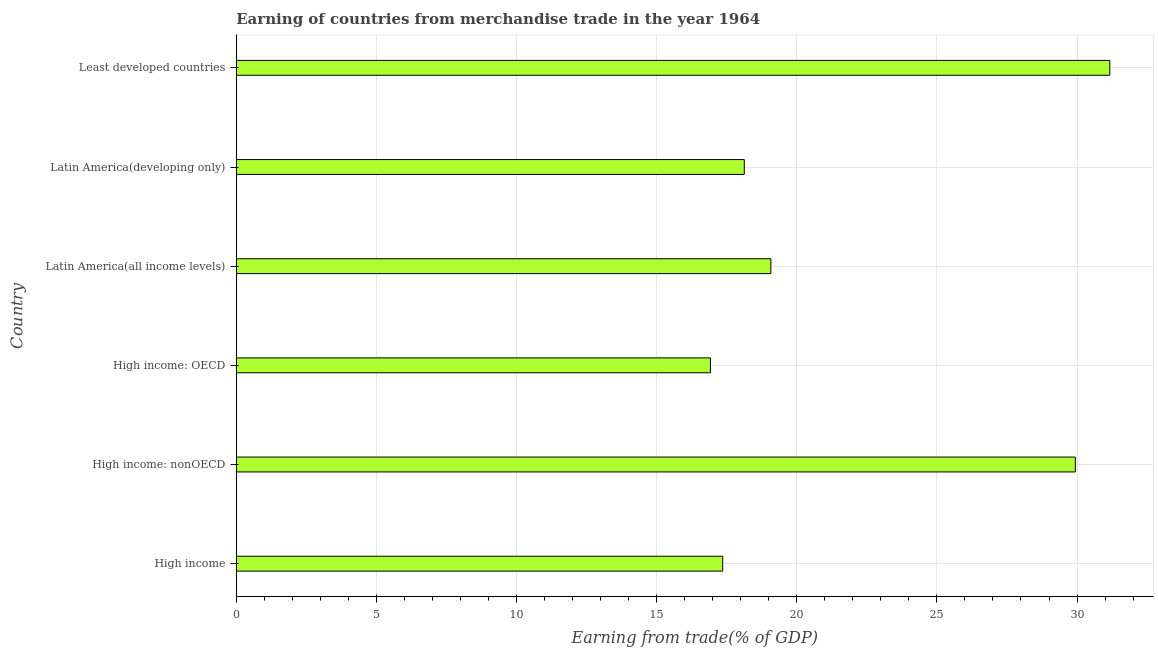Does the graph contain grids?
Your answer should be compact. Yes. What is the title of the graph?
Provide a short and direct response. Earning of countries from merchandise trade in the year 1964. What is the label or title of the X-axis?
Ensure brevity in your answer.  Earning from trade(% of GDP). What is the label or title of the Y-axis?
Your answer should be compact. Country. What is the earning from merchandise trade in High income: nonOECD?
Give a very brief answer. 29.94. Across all countries, what is the maximum earning from merchandise trade?
Provide a succinct answer. 31.17. Across all countries, what is the minimum earning from merchandise trade?
Offer a very short reply. 16.92. In which country was the earning from merchandise trade maximum?
Keep it short and to the point. Least developed countries. In which country was the earning from merchandise trade minimum?
Ensure brevity in your answer.  High income: OECD. What is the sum of the earning from merchandise trade?
Your answer should be compact. 132.59. What is the difference between the earning from merchandise trade in High income: OECD and Latin America(developing only)?
Your response must be concise. -1.21. What is the average earning from merchandise trade per country?
Your response must be concise. 22.1. What is the median earning from merchandise trade?
Keep it short and to the point. 18.6. What is the ratio of the earning from merchandise trade in High income to that in High income: nonOECD?
Keep it short and to the point. 0.58. Is the earning from merchandise trade in High income: OECD less than that in Latin America(developing only)?
Provide a short and direct response. Yes. What is the difference between the highest and the second highest earning from merchandise trade?
Give a very brief answer. 1.23. What is the difference between the highest and the lowest earning from merchandise trade?
Make the answer very short. 14.25. In how many countries, is the earning from merchandise trade greater than the average earning from merchandise trade taken over all countries?
Give a very brief answer. 2. Are all the bars in the graph horizontal?
Give a very brief answer. Yes. Are the values on the major ticks of X-axis written in scientific E-notation?
Provide a succinct answer. No. What is the Earning from trade(% of GDP) in High income?
Provide a short and direct response. 17.36. What is the Earning from trade(% of GDP) of High income: nonOECD?
Your answer should be very brief. 29.94. What is the Earning from trade(% of GDP) in High income: OECD?
Your response must be concise. 16.92. What is the Earning from trade(% of GDP) in Latin America(all income levels)?
Provide a succinct answer. 19.08. What is the Earning from trade(% of GDP) of Latin America(developing only)?
Ensure brevity in your answer.  18.13. What is the Earning from trade(% of GDP) of Least developed countries?
Provide a succinct answer. 31.17. What is the difference between the Earning from trade(% of GDP) in High income and High income: nonOECD?
Offer a very short reply. -12.58. What is the difference between the Earning from trade(% of GDP) in High income and High income: OECD?
Give a very brief answer. 0.44. What is the difference between the Earning from trade(% of GDP) in High income and Latin America(all income levels)?
Your answer should be very brief. -1.72. What is the difference between the Earning from trade(% of GDP) in High income and Latin America(developing only)?
Your answer should be compact. -0.77. What is the difference between the Earning from trade(% of GDP) in High income and Least developed countries?
Keep it short and to the point. -13.81. What is the difference between the Earning from trade(% of GDP) in High income: nonOECD and High income: OECD?
Ensure brevity in your answer.  13.02. What is the difference between the Earning from trade(% of GDP) in High income: nonOECD and Latin America(all income levels)?
Provide a succinct answer. 10.86. What is the difference between the Earning from trade(% of GDP) in High income: nonOECD and Latin America(developing only)?
Offer a terse response. 11.81. What is the difference between the Earning from trade(% of GDP) in High income: nonOECD and Least developed countries?
Your answer should be compact. -1.23. What is the difference between the Earning from trade(% of GDP) in High income: OECD and Latin America(all income levels)?
Your response must be concise. -2.16. What is the difference between the Earning from trade(% of GDP) in High income: OECD and Latin America(developing only)?
Offer a terse response. -1.21. What is the difference between the Earning from trade(% of GDP) in High income: OECD and Least developed countries?
Offer a very short reply. -14.25. What is the difference between the Earning from trade(% of GDP) in Latin America(all income levels) and Latin America(developing only)?
Give a very brief answer. 0.95. What is the difference between the Earning from trade(% of GDP) in Latin America(all income levels) and Least developed countries?
Give a very brief answer. -12.09. What is the difference between the Earning from trade(% of GDP) in Latin America(developing only) and Least developed countries?
Make the answer very short. -13.04. What is the ratio of the Earning from trade(% of GDP) in High income to that in High income: nonOECD?
Provide a succinct answer. 0.58. What is the ratio of the Earning from trade(% of GDP) in High income to that in Latin America(all income levels)?
Provide a succinct answer. 0.91. What is the ratio of the Earning from trade(% of GDP) in High income to that in Least developed countries?
Ensure brevity in your answer.  0.56. What is the ratio of the Earning from trade(% of GDP) in High income: nonOECD to that in High income: OECD?
Give a very brief answer. 1.77. What is the ratio of the Earning from trade(% of GDP) in High income: nonOECD to that in Latin America(all income levels)?
Keep it short and to the point. 1.57. What is the ratio of the Earning from trade(% of GDP) in High income: nonOECD to that in Latin America(developing only)?
Provide a succinct answer. 1.65. What is the ratio of the Earning from trade(% of GDP) in High income: OECD to that in Latin America(all income levels)?
Make the answer very short. 0.89. What is the ratio of the Earning from trade(% of GDP) in High income: OECD to that in Latin America(developing only)?
Offer a very short reply. 0.93. What is the ratio of the Earning from trade(% of GDP) in High income: OECD to that in Least developed countries?
Provide a short and direct response. 0.54. What is the ratio of the Earning from trade(% of GDP) in Latin America(all income levels) to that in Latin America(developing only)?
Provide a short and direct response. 1.05. What is the ratio of the Earning from trade(% of GDP) in Latin America(all income levels) to that in Least developed countries?
Provide a short and direct response. 0.61. What is the ratio of the Earning from trade(% of GDP) in Latin America(developing only) to that in Least developed countries?
Make the answer very short. 0.58. 